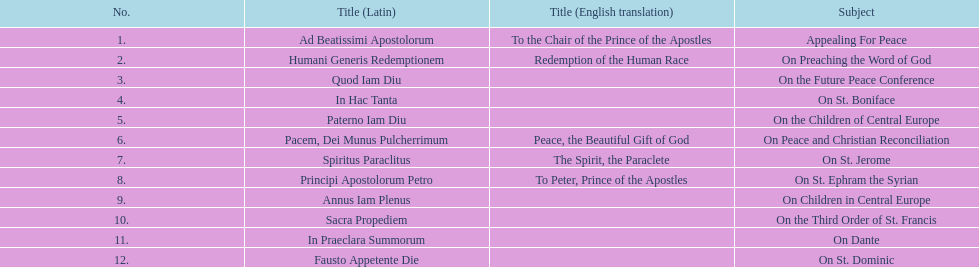Which english translation is mentioned first in the table? To the Chair of the Prince of the Apostles. 